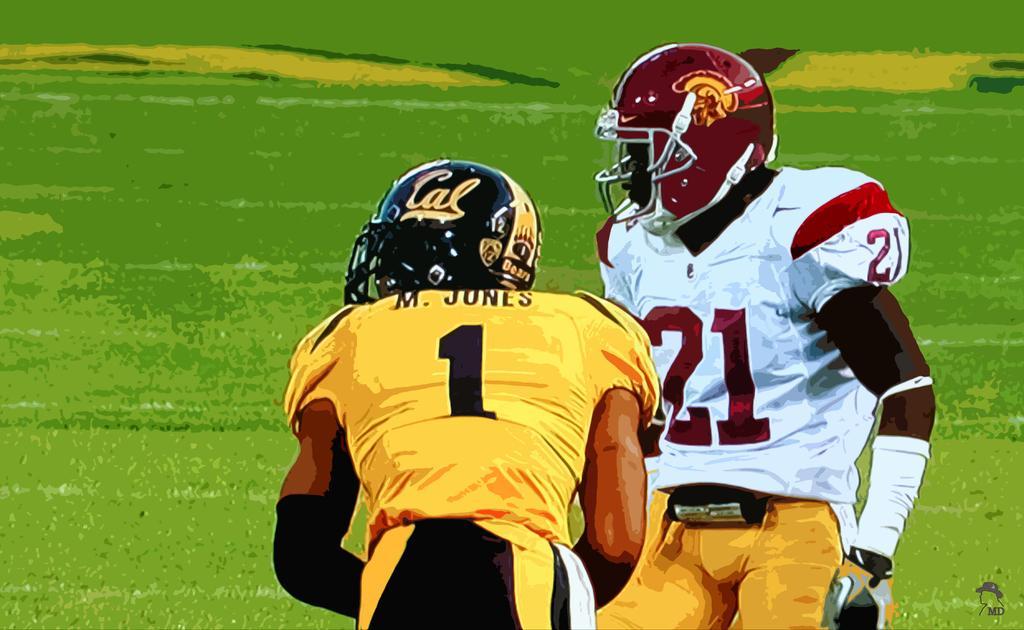Can you describe this image briefly? In this image there are two rugby players standing on the ground. They are wearing the helmets and gloves. 